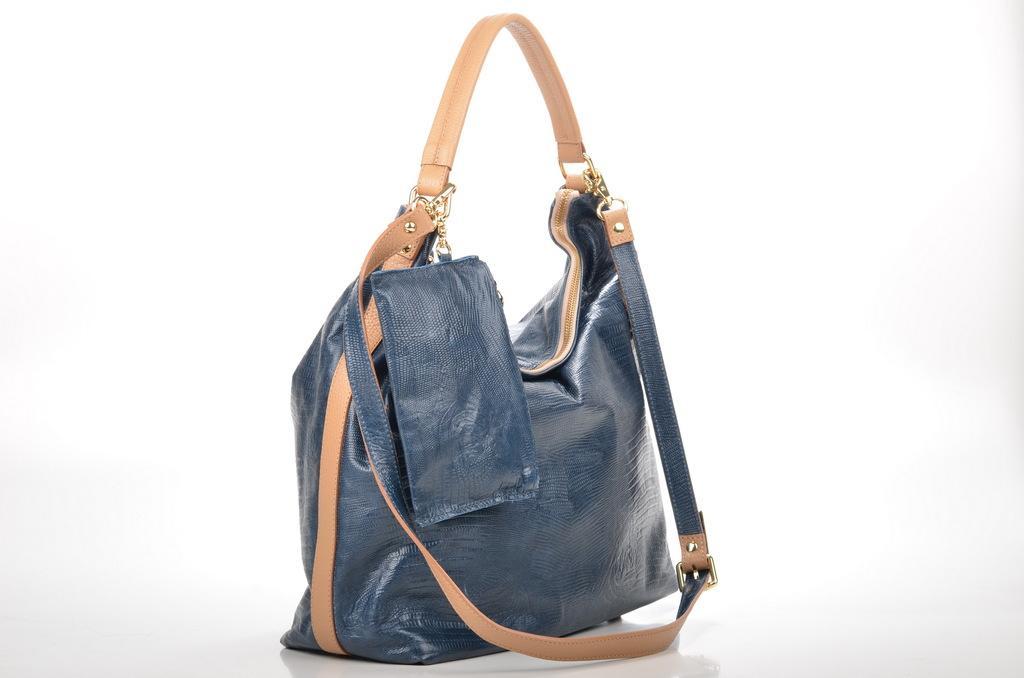Please provide a concise description of this image. In this. picture we can see blue color bag with chocolate color belt. 